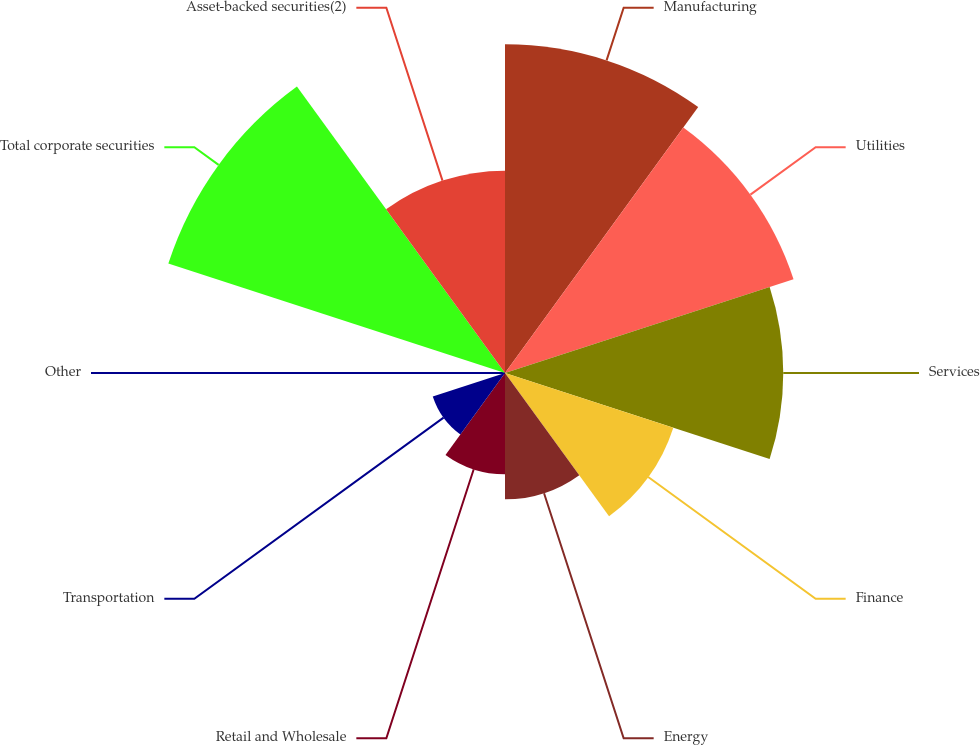Convert chart to OTSL. <chart><loc_0><loc_0><loc_500><loc_500><pie_chart><fcel>Manufacturing<fcel>Utilities<fcel>Services<fcel>Finance<fcel>Energy<fcel>Retail and Wholesale<fcel>Transportation<fcel>Other<fcel>Total corporate securities<fcel>Asset-backed securities(2)<nl><fcel>16.88%<fcel>15.58%<fcel>14.29%<fcel>9.09%<fcel>6.49%<fcel>5.2%<fcel>3.9%<fcel>0.0%<fcel>18.18%<fcel>10.39%<nl></chart> 